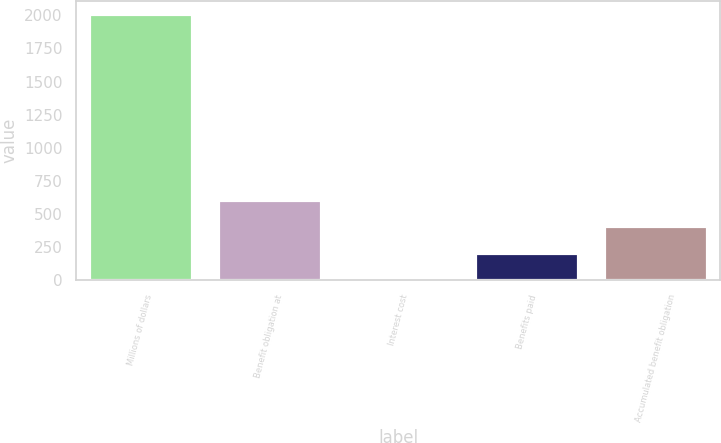<chart> <loc_0><loc_0><loc_500><loc_500><bar_chart><fcel>Millions of dollars<fcel>Benefit obligation at<fcel>Interest cost<fcel>Benefits paid<fcel>Accumulated benefit obligation<nl><fcel>2007<fcel>607.7<fcel>8<fcel>207.9<fcel>407.8<nl></chart> 